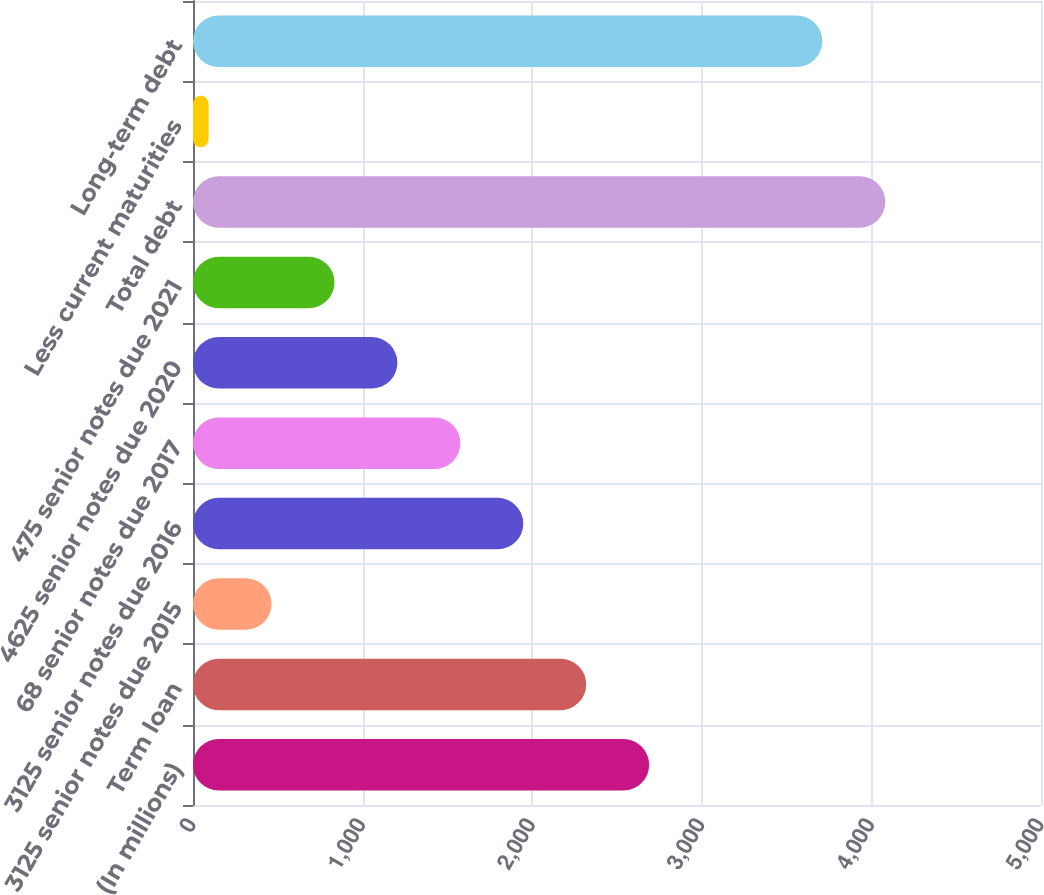Convert chart to OTSL. <chart><loc_0><loc_0><loc_500><loc_500><bar_chart><fcel>(In millions)<fcel>Term loan<fcel>3125 senior notes due 2015<fcel>3125 senior notes due 2016<fcel>68 senior notes due 2017<fcel>4625 senior notes due 2020<fcel>475 senior notes due 2021<fcel>Total debt<fcel>Less current maturities<fcel>Long-term debt<nl><fcel>2689.7<fcel>2318.6<fcel>463.1<fcel>1947.5<fcel>1576.4<fcel>1205.3<fcel>834.2<fcel>4082.1<fcel>92<fcel>3711<nl></chart> 